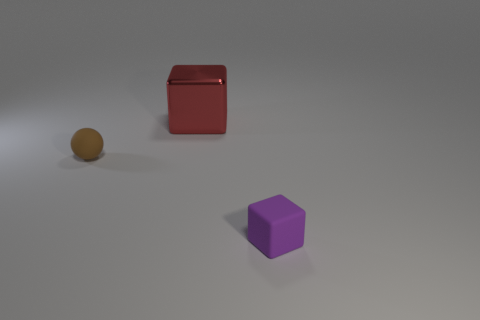Add 3 purple cubes. How many objects exist? 6 Subtract all spheres. How many objects are left? 2 Subtract all blocks. Subtract all small spheres. How many objects are left? 0 Add 3 brown matte things. How many brown matte things are left? 4 Add 2 big red metallic blocks. How many big red metallic blocks exist? 3 Subtract 1 brown balls. How many objects are left? 2 